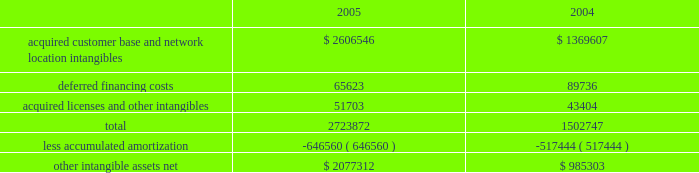American tower corporation and subsidiaries notes to consolidated financial statements 2014 ( continued ) the company has selected december 1 as the date to perform its annual impairment test .
In performing its 2005 and 2004 testing , the company completed an internal appraisal and estimated the fair value of the rental and management reporting unit that contains goodwill utilizing future discounted cash flows and market information .
Based on the appraisals performed , the company determined that goodwill in its rental and management segment was not impaired .
The company 2019s other intangible assets subject to amortization consist of the following as of december 31 , ( in thousands ) : .
The company amortizes its intangible assets over periods ranging from three to fifteen years .
Amortization of intangible assets for the years ended december 31 , 2005 and 2004 aggregated approximately $ 136.0 million and $ 97.8 million , respectively ( excluding amortization of deferred financing costs , which is included in interest expense ) .
The company expects to record amortization expense of approximately $ 183.6 million , $ 178.3 million , $ 174.4 million , $ 172.7 million and $ 170.3 million , for the years ended december 31 , 2006 , 2007 , 2008 , 2009 and 2010 , respectively .
These amounts are subject to changes in estimates until the preliminary allocation of the spectrasite purchase price is finalized .
Notes receivable in 2000 , the company loaned tv azteca , s.a .
De c.v .
( tv azteca ) , the owner of a major national television network in mexico , $ 119.8 million .
The loan , which initially bore interest at 12.87% ( 12.87 % ) , payable quarterly , was discounted by the company , as the fair value interest rate at the date of the loan was determined to be 14.25% ( 14.25 % ) .
The loan was amended effective january 1 , 2003 to increase the original interest rate to 13.11% ( 13.11 % ) .
As of december 31 , 2005 and 2004 , approximately $ 119.8 million undiscounted ( $ 108.2 million discounted ) under the loan was outstanding and included in notes receivable and other long-term assets in the accompanying consolidated balance sheets .
The term of the loan is seventy years ; however , the loan may be prepaid by tv azteca without penalty during the last fifty years of the agreement .
The discount on the loan is being amortized to interest income 2014tv azteca , net , using the effective interest method over the seventy-year term of the loan .
Simultaneous with the signing of the loan agreement , the company also entered into a seventy year economic rights agreement with tv azteca regarding space not used by tv azteca on approximately 190 of its broadcast towers .
In exchange for the issuance of the below market interest rate loan discussed above and the annual payment of $ 1.5 million to tv azteca ( under the economic rights agreement ) , the company has the right to market and lease the unused tower space on the broadcast towers ( the economic rights ) .
Tv azteca retains title to these towers and is responsible for their operation and maintenance .
The company is entitled to 100% ( 100 % ) of the revenues generated from leases with tenants on the unused space and is responsible for any incremental operating expenses associated with those tenants. .
Assuming that intangible asset will be sold , what will be the accumulated deprecation at the end of 2007 , in millions? 
Computations: (((646560 / 1000) + 183.6) + 178.3)
Answer: 1008.46. 